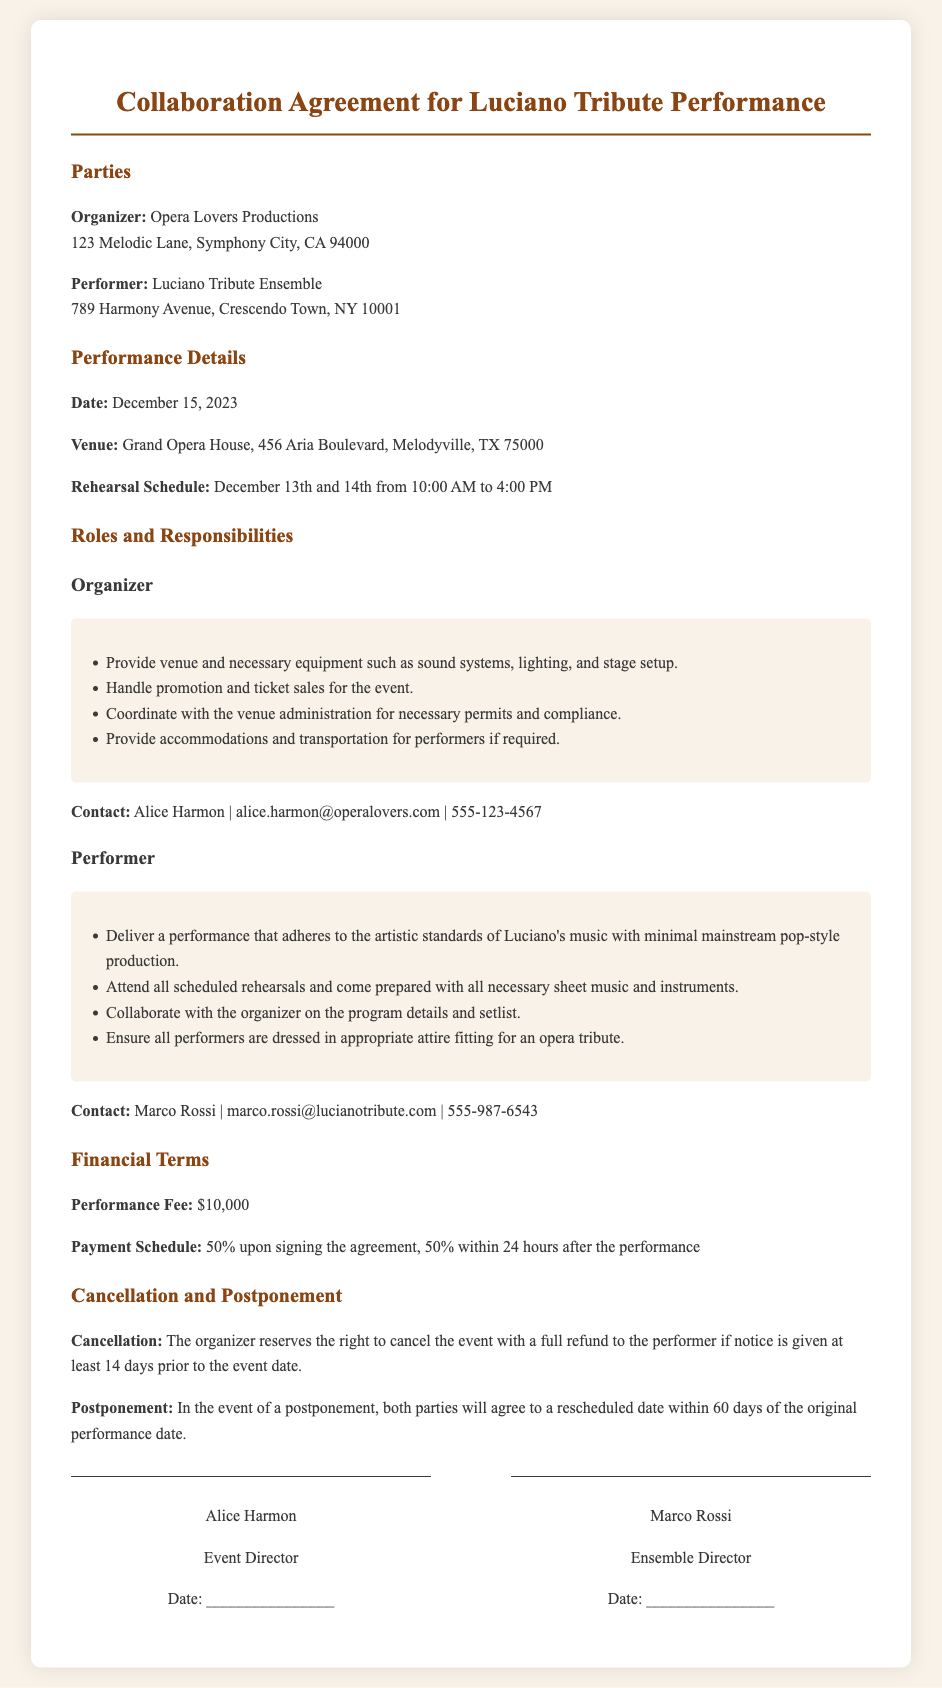what is the date of the performance? The document specifies that the performance is scheduled for December 15, 2023.
Answer: December 15, 2023 who are the parties involved in the agreement? The document outlines the organizer and the performer involved in the collaboration, which are Opera Lovers Productions and Luciano Tribute Ensemble.
Answer: Opera Lovers Productions, Luciano Tribute Ensemble what is the venue for the performance? The venue where the performance will take place is clearly stated in the document.
Answer: Grand Opera House how much is the performance fee? The document states the performance fee that the performer will receive for the event.
Answer: $10,000 what is the payment schedule? The document describes the terms and timeline for the payment related to the performance fee.
Answer: 50% upon signing the agreement, 50% within 24 hours after the performance how many days prior notice is required for cancellation? The document indicates how much prior notice is needed for the organizer to cancel the event.
Answer: 14 days who is the contact person for the organizer? The document provides the name of the contact person for the organizer along with her details.
Answer: Alice Harmon what must the performer ensure regarding their attire? The performer has a specific responsibility regarding their attire as mentioned in the document.
Answer: Appropriate attire fitting for an opera tribute what must the performer bring to rehearsals? The responsibilities listed for the performer include items they need to have for rehearsals.
Answer: All necessary sheet music and instruments 